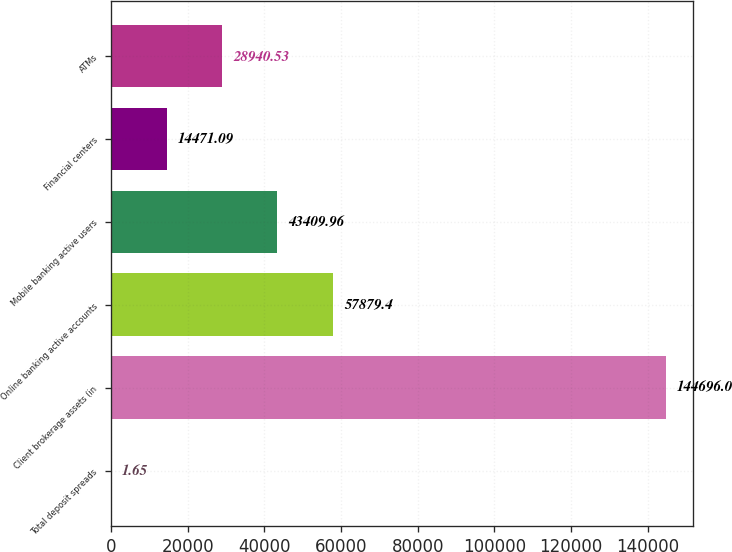<chart> <loc_0><loc_0><loc_500><loc_500><bar_chart><fcel>Total deposit spreads<fcel>Client brokerage assets (in<fcel>Online banking active accounts<fcel>Mobile banking active users<fcel>Financial centers<fcel>ATMs<nl><fcel>1.65<fcel>144696<fcel>57879.4<fcel>43410<fcel>14471.1<fcel>28940.5<nl></chart> 